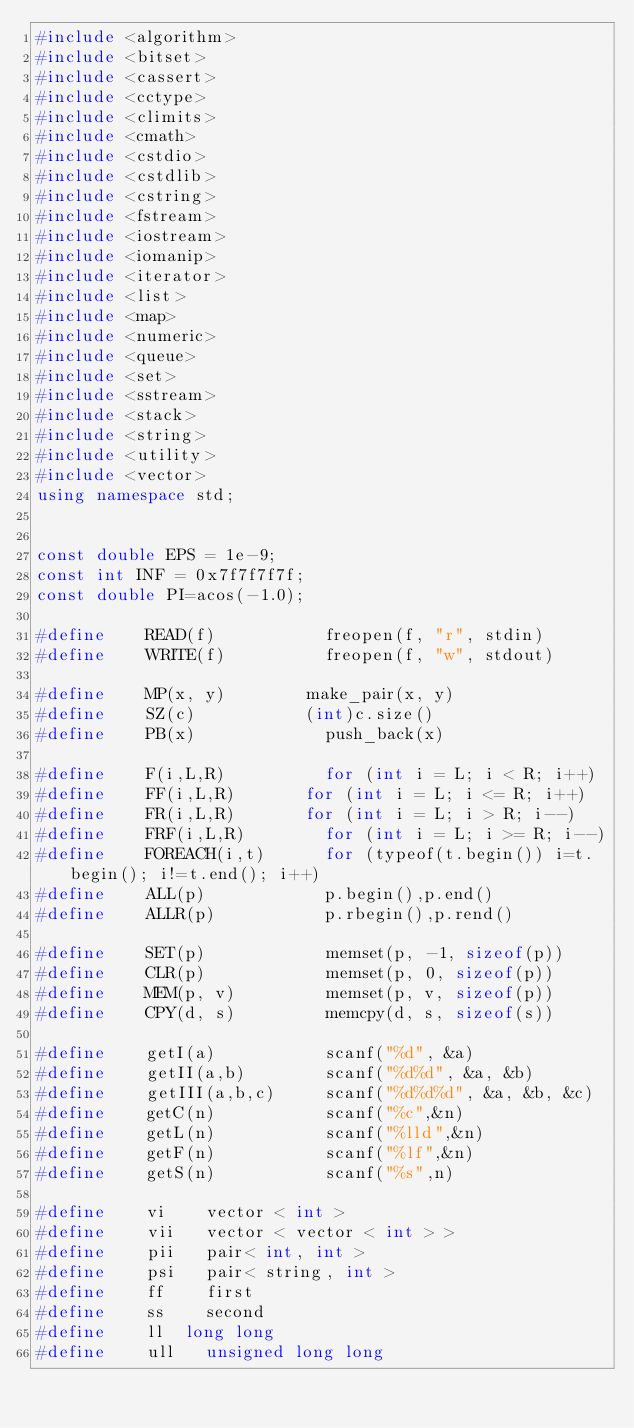<code> <loc_0><loc_0><loc_500><loc_500><_C++_>#include <algorithm>
#include <bitset>
#include <cassert>
#include <cctype>
#include <climits>
#include <cmath>
#include <cstdio>
#include <cstdlib>
#include <cstring>
#include <fstream>
#include <iostream>
#include <iomanip>
#include <iterator>
#include <list>
#include <map>
#include <numeric>
#include <queue>
#include <set>
#include <sstream>
#include <stack>
#include <string>
#include <utility>
#include <vector>
using namespace std;


const double EPS = 1e-9;
const int INF = 0x7f7f7f7f;
const double PI=acos(-1.0);

#define    READ(f) 	         freopen(f, "r", stdin)
#define    WRITE(f)   	     freopen(f, "w", stdout)

#define    MP(x, y) 	     make_pair(x, y)
#define    SZ(c) 	         (int)c.size()
#define    PB(x)             push_back(x)

#define    F(i,L,R)	         for (int i = L; i < R; i++)
#define    FF(i,L,R) 	     for (int i = L; i <= R; i++)
#define    FR(i,L,R) 	     for (int i = L; i > R; i--)
#define    FRF(i,L,R) 	     for (int i = L; i >= R; i--)
#define    FOREACH(i,t)      for (typeof(t.begin()) i=t.begin(); i!=t.end(); i++)
#define    ALL(p) 	         p.begin(),p.end()
#define    ALLR(p) 	         p.rbegin(),p.rend()

#define    SET(p) 	         memset(p, -1, sizeof(p))
#define    CLR(p)            memset(p, 0, sizeof(p))
#define    MEM(p, v)         memset(p, v, sizeof(p))
#define    CPY(d, s)         memcpy(d, s, sizeof(s))

#define    getI(a) 	         scanf("%d", &a)
#define    getII(a,b) 	     scanf("%d%d", &a, &b)
#define    getIII(a,b,c)     scanf("%d%d%d", &a, &b, &c)
#define    getC(n)           scanf("%c",&n)
#define    getL(n)           scanf("%lld",&n)
#define    getF(n)           scanf("%lf",&n)
#define    getS(n)           scanf("%s",n)

#define    vi 	 vector < int >
#define    vii 	 vector < vector < int > >
#define    pii 	 pair< int, int >
#define    psi 	 pair< string, int >
#define    ff 	 first
#define    ss 	 second
#define    ll	 long long
#define    ull 	 unsigned long long</code> 